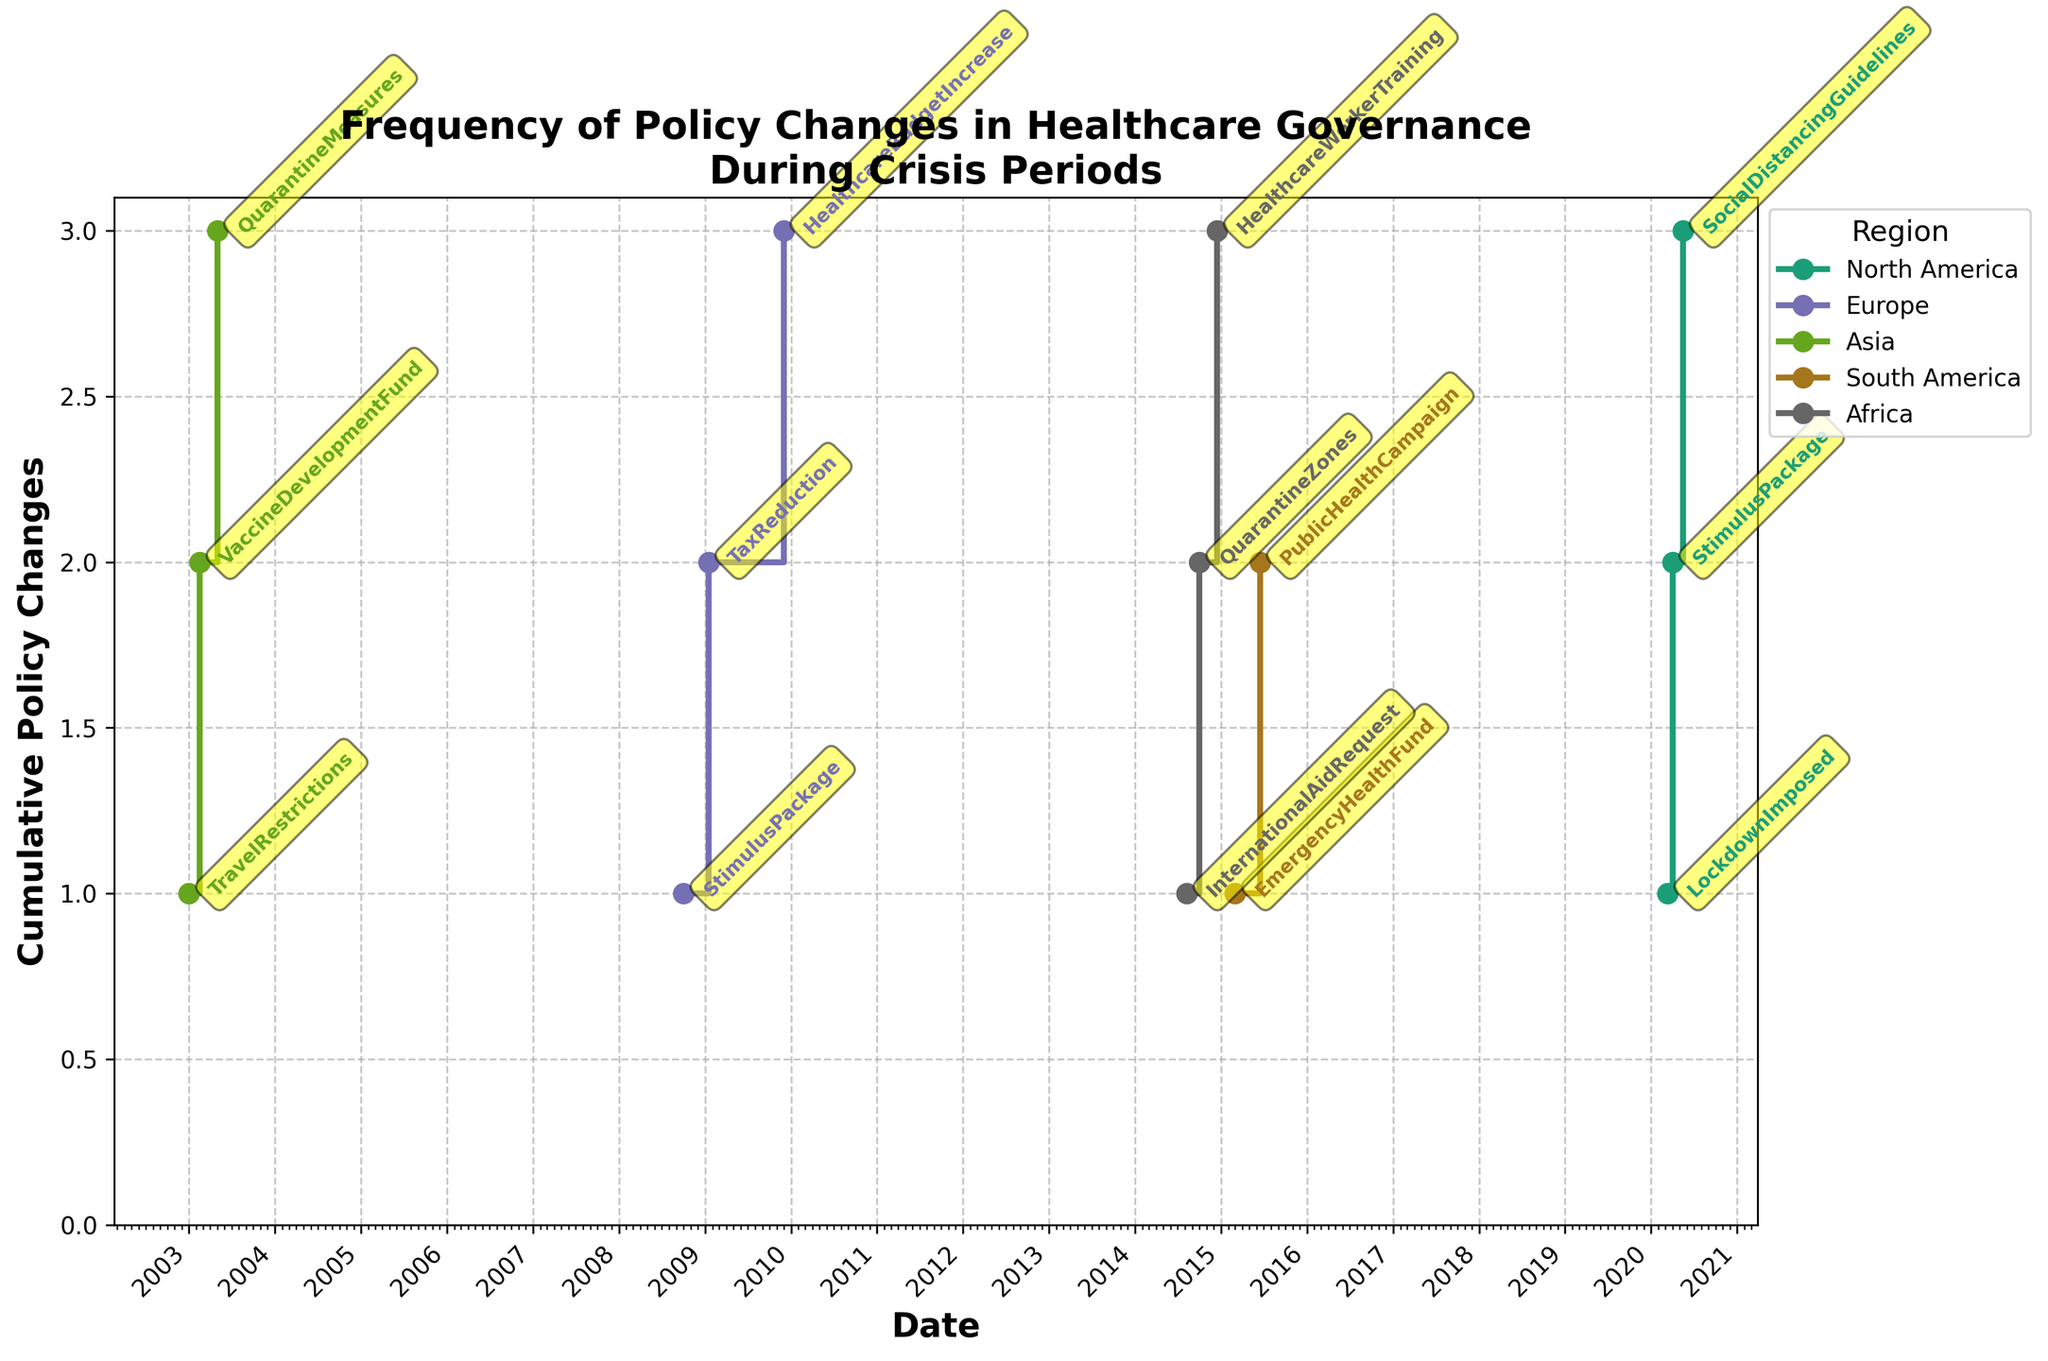Which region has the earliest policy change? Looking at the x-axis (dates) and tracing to the earliest date which is '2003-01-01' for Asia related to Avian Flu.
Answer: Asia Which region implemented the highest number of cumulative policy changes during a single crisis? By observing the y-axis values and cumulative stair-step rises, we see that 'North America' during COVID-19 shows 3 steps reaching the highest cumulative count.
Answer: North America What type of policy change occurred on 2009-01-15 in Europe? Locate 2009-01-15 on the x-axis, follow to the annotation, and see the policy labeled as 'TaxReduction.'
Answer: TaxReduction During the COVID-19 pandemic, which type of policy was implemented last in North America? For North America's COVID-19 data, locate the latest date (2020-05-15) on the x-axis and check the policy annotated as 'SocialDistancingGuidelines.'
Answer: SocialDistancingGuidelines Compare the frequency of policy changes between North America and Africa. Which had more changes? Count the number of steps for both regions. North America has 3 steps, whereas Africa has 3 steps. Both regions have the same frequency.
Answer: Both regions had 3 changes How does the frequency of policy changes during the Ebola Outbreak in Africa compare to the Avian Flu pandemic in Asia? Both regions show 3 steps for each crisis, indicating equal frequency of policy changes.
Answer: Equal How many policy changes occurred in Europe during the Economic Recession before 2009? Identify policy changes before 2009, which falls before the dates 2009-01-01. Europe shows 1 step before 2009 (2008-10-01).
Answer: 1 What is the nature of the crisis that led to the earliest policy change in the dataset? The earliest policy change is on '2003-01-01' in Asia. The nature of the crisis is marked as a 'Pandemic' for Avian Flu.
Answer: Pandemic Which region had the longest duration between the start and the end of policy changes during a single crisis? Observe the periods covered by the steps in the graph. Europe during Economic Recession spans from 2008-10-01 to 2009-11-30, making it the longest duration.
Answer: Europe How often did Africa request international aid during the Ebola Outbreak? Trace the annotations specific to the Ebola Outbreak. Identify 'InternationalAidRequest' occurred once on 2014-08-08.
Answer: Once 